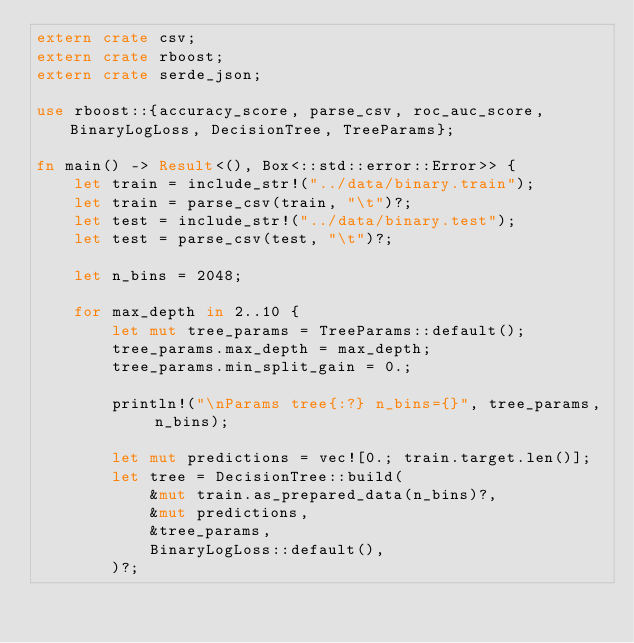Convert code to text. <code><loc_0><loc_0><loc_500><loc_500><_Rust_>extern crate csv;
extern crate rboost;
extern crate serde_json;

use rboost::{accuracy_score, parse_csv, roc_auc_score, BinaryLogLoss, DecisionTree, TreeParams};

fn main() -> Result<(), Box<::std::error::Error>> {
    let train = include_str!("../data/binary.train");
    let train = parse_csv(train, "\t")?;
    let test = include_str!("../data/binary.test");
    let test = parse_csv(test, "\t")?;

    let n_bins = 2048;

    for max_depth in 2..10 {
        let mut tree_params = TreeParams::default();
        tree_params.max_depth = max_depth;
        tree_params.min_split_gain = 0.;

        println!("\nParams tree{:?} n_bins={}", tree_params, n_bins);

        let mut predictions = vec![0.; train.target.len()];
        let tree = DecisionTree::build(
            &mut train.as_prepared_data(n_bins)?,
            &mut predictions,
            &tree_params,
            BinaryLogLoss::default(),
        )?;
</code> 